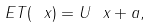<formula> <loc_0><loc_0><loc_500><loc_500>E T ( \ x ) = U \ x + a ,</formula> 